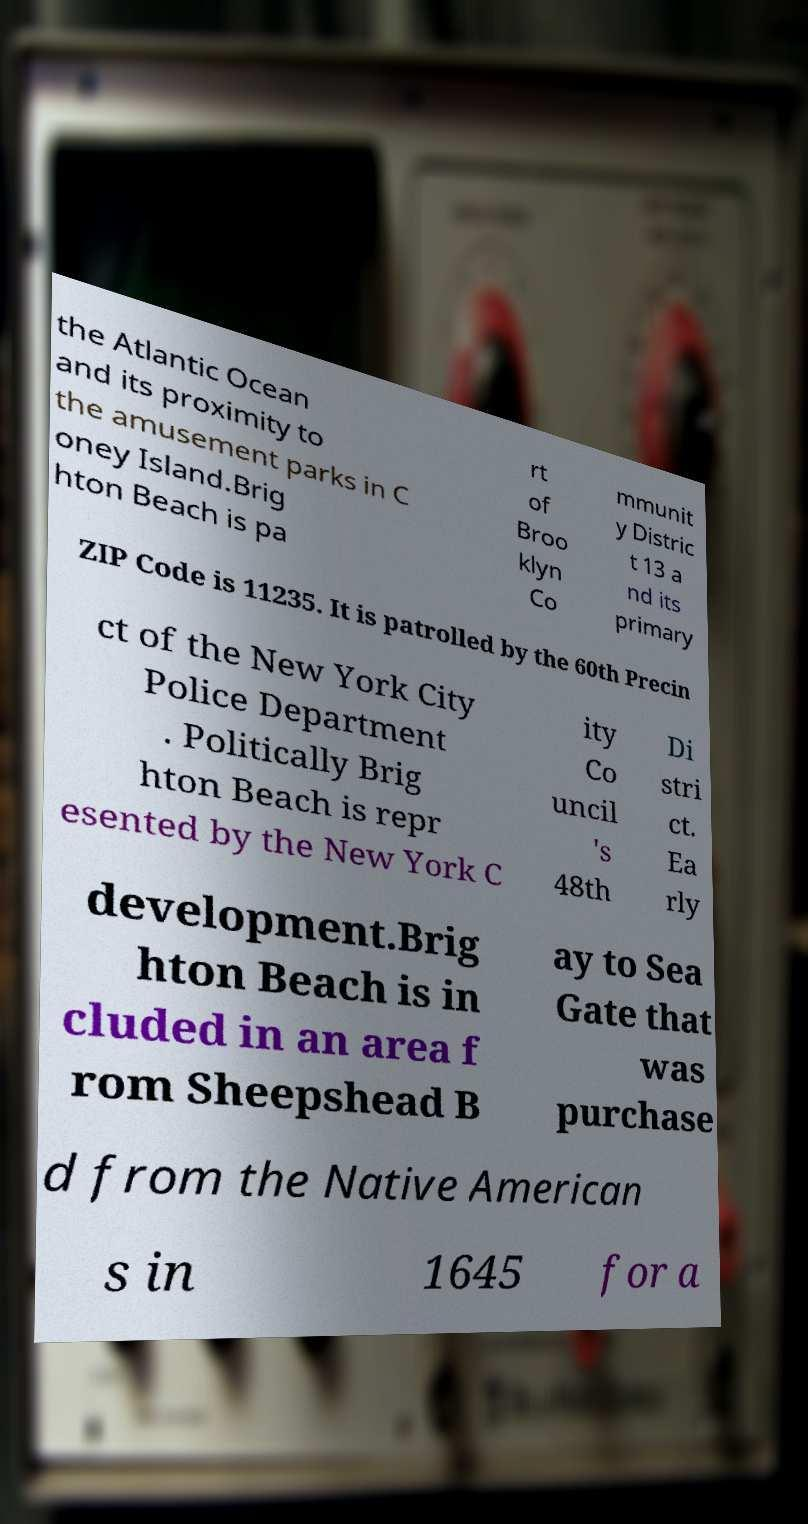There's text embedded in this image that I need extracted. Can you transcribe it verbatim? the Atlantic Ocean and its proximity to the amusement parks in C oney Island.Brig hton Beach is pa rt of Broo klyn Co mmunit y Distric t 13 a nd its primary ZIP Code is 11235. It is patrolled by the 60th Precin ct of the New York City Police Department . Politically Brig hton Beach is repr esented by the New York C ity Co uncil 's 48th Di stri ct. Ea rly development.Brig hton Beach is in cluded in an area f rom Sheepshead B ay to Sea Gate that was purchase d from the Native American s in 1645 for a 